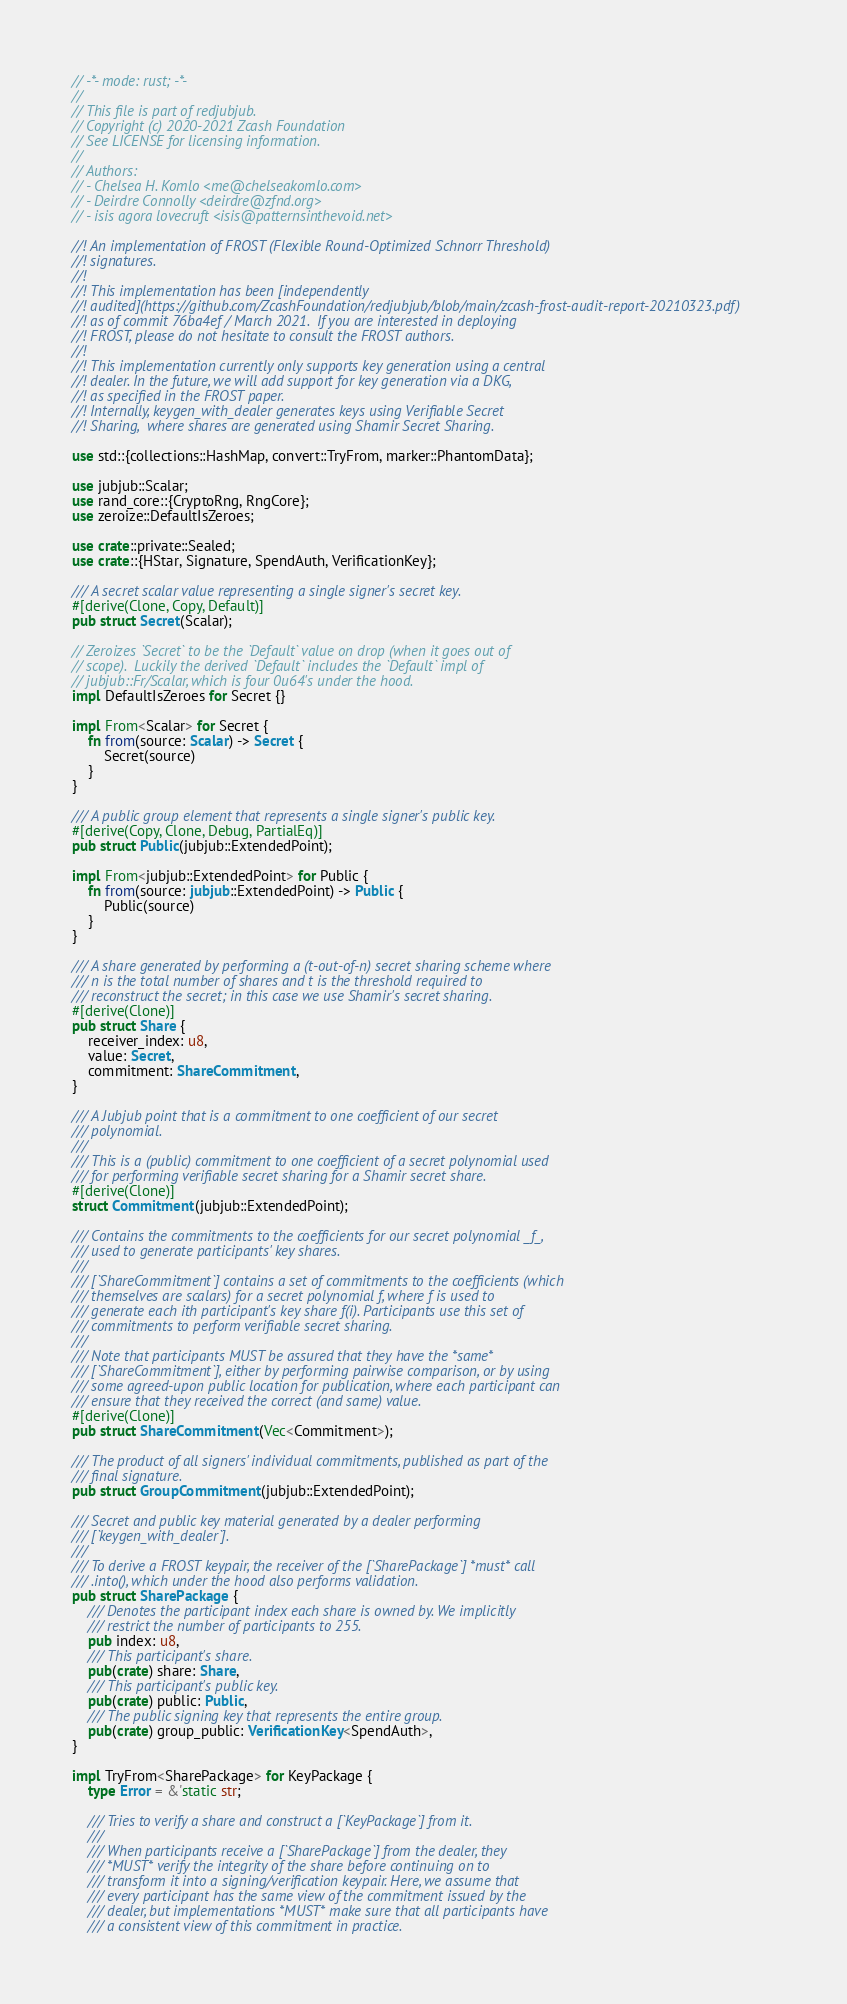Convert code to text. <code><loc_0><loc_0><loc_500><loc_500><_Rust_>// -*- mode: rust; -*-
//
// This file is part of redjubjub.
// Copyright (c) 2020-2021 Zcash Foundation
// See LICENSE for licensing information.
//
// Authors:
// - Chelsea H. Komlo <me@chelseakomlo.com>
// - Deirdre Connolly <deirdre@zfnd.org>
// - isis agora lovecruft <isis@patternsinthevoid.net>

//! An implementation of FROST (Flexible Round-Optimized Schnorr Threshold)
//! signatures.
//!
//! This implementation has been [independently
//! audited](https://github.com/ZcashFoundation/redjubjub/blob/main/zcash-frost-audit-report-20210323.pdf)
//! as of commit 76ba4ef / March 2021.  If you are interested in deploying
//! FROST, please do not hesitate to consult the FROST authors.
//!
//! This implementation currently only supports key generation using a central
//! dealer. In the future, we will add support for key generation via a DKG,
//! as specified in the FROST paper.
//! Internally, keygen_with_dealer generates keys using Verifiable Secret
//! Sharing,  where shares are generated using Shamir Secret Sharing.

use std::{collections::HashMap, convert::TryFrom, marker::PhantomData};

use jubjub::Scalar;
use rand_core::{CryptoRng, RngCore};
use zeroize::DefaultIsZeroes;

use crate::private::Sealed;
use crate::{HStar, Signature, SpendAuth, VerificationKey};

/// A secret scalar value representing a single signer's secret key.
#[derive(Clone, Copy, Default)]
pub struct Secret(Scalar);

// Zeroizes `Secret` to be the `Default` value on drop (when it goes out of
// scope).  Luckily the derived `Default` includes the `Default` impl of
// jubjub::Fr/Scalar, which is four 0u64's under the hood.
impl DefaultIsZeroes for Secret {}

impl From<Scalar> for Secret {
    fn from(source: Scalar) -> Secret {
        Secret(source)
    }
}

/// A public group element that represents a single signer's public key.
#[derive(Copy, Clone, Debug, PartialEq)]
pub struct Public(jubjub::ExtendedPoint);

impl From<jubjub::ExtendedPoint> for Public {
    fn from(source: jubjub::ExtendedPoint) -> Public {
        Public(source)
    }
}

/// A share generated by performing a (t-out-of-n) secret sharing scheme where
/// n is the total number of shares and t is the threshold required to
/// reconstruct the secret; in this case we use Shamir's secret sharing.
#[derive(Clone)]
pub struct Share {
    receiver_index: u8,
    value: Secret,
    commitment: ShareCommitment,
}

/// A Jubjub point that is a commitment to one coefficient of our secret
/// polynomial.
///
/// This is a (public) commitment to one coefficient of a secret polynomial used
/// for performing verifiable secret sharing for a Shamir secret share.
#[derive(Clone)]
struct Commitment(jubjub::ExtendedPoint);

/// Contains the commitments to the coefficients for our secret polynomial _f_,
/// used to generate participants' key shares.
///
/// [`ShareCommitment`] contains a set of commitments to the coefficients (which
/// themselves are scalars) for a secret polynomial f, where f is used to
/// generate each ith participant's key share f(i). Participants use this set of
/// commitments to perform verifiable secret sharing.
///
/// Note that participants MUST be assured that they have the *same*
/// [`ShareCommitment`], either by performing pairwise comparison, or by using
/// some agreed-upon public location for publication, where each participant can
/// ensure that they received the correct (and same) value.
#[derive(Clone)]
pub struct ShareCommitment(Vec<Commitment>);

/// The product of all signers' individual commitments, published as part of the
/// final signature.
pub struct GroupCommitment(jubjub::ExtendedPoint);

/// Secret and public key material generated by a dealer performing
/// [`keygen_with_dealer`].
///
/// To derive a FROST keypair, the receiver of the [`SharePackage`] *must* call
/// .into(), which under the hood also performs validation.
pub struct SharePackage {
    /// Denotes the participant index each share is owned by. We implicitly
    /// restrict the number of participants to 255.
    pub index: u8,
    /// This participant's share.
    pub(crate) share: Share,
    /// This participant's public key.
    pub(crate) public: Public,
    /// The public signing key that represents the entire group.
    pub(crate) group_public: VerificationKey<SpendAuth>,
}

impl TryFrom<SharePackage> for KeyPackage {
    type Error = &'static str;

    /// Tries to verify a share and construct a [`KeyPackage`] from it.
    ///
    /// When participants receive a [`SharePackage`] from the dealer, they
    /// *MUST* verify the integrity of the share before continuing on to
    /// transform it into a signing/verification keypair. Here, we assume that
    /// every participant has the same view of the commitment issued by the
    /// dealer, but implementations *MUST* make sure that all participants have
    /// a consistent view of this commitment in practice.</code> 